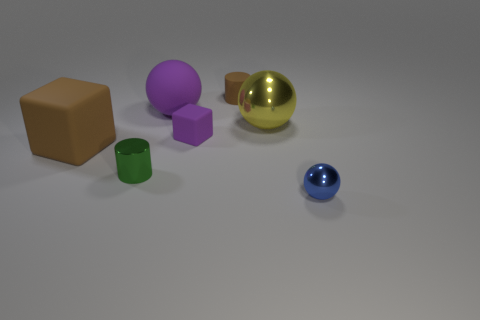Do the brown cylinder and the rubber ball have the same size?
Your response must be concise. No. What number of large cubes have the same material as the big purple object?
Your answer should be compact. 1. The purple thing that is the same shape as the blue metal object is what size?
Provide a short and direct response. Large. There is a brown matte thing that is in front of the big metallic thing; is its shape the same as the blue thing?
Give a very brief answer. No. What is the shape of the small object that is to the right of the cylinder that is to the right of the purple matte block?
Offer a terse response. Sphere. Are there any other things that are the same shape as the small green metallic object?
Your response must be concise. Yes. What color is the other object that is the same shape as the large brown object?
Give a very brief answer. Purple. There is a big matte sphere; does it have the same color as the object that is in front of the metal cylinder?
Keep it short and to the point. No. There is a shiny object that is on the right side of the small matte cube and in front of the tiny purple rubber thing; what is its shape?
Ensure brevity in your answer.  Sphere. Is the number of small cylinders less than the number of big yellow cubes?
Ensure brevity in your answer.  No. 